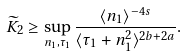Convert formula to latex. <formula><loc_0><loc_0><loc_500><loc_500>\widetilde { K } _ { 2 } \geq \sup _ { n _ { 1 } , \tau _ { 1 } } \frac { \langle n _ { 1 } \rangle ^ { - 4 s } } { \langle \tau _ { 1 } + n _ { 1 } ^ { 2 } \rangle ^ { 2 b + 2 a } } .</formula> 